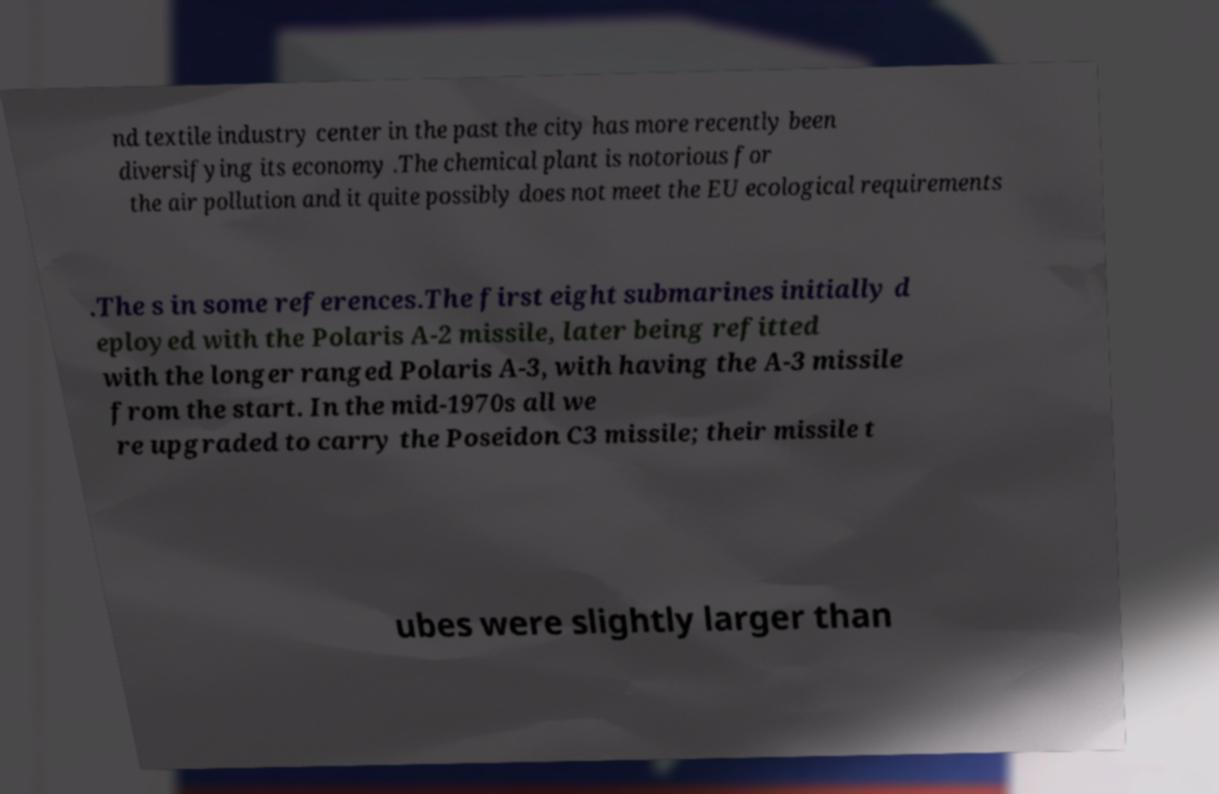There's text embedded in this image that I need extracted. Can you transcribe it verbatim? nd textile industry center in the past the city has more recently been diversifying its economy .The chemical plant is notorious for the air pollution and it quite possibly does not meet the EU ecological requirements .The s in some references.The first eight submarines initially d eployed with the Polaris A-2 missile, later being refitted with the longer ranged Polaris A-3, with having the A-3 missile from the start. In the mid-1970s all we re upgraded to carry the Poseidon C3 missile; their missile t ubes were slightly larger than 